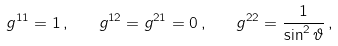Convert formula to latex. <formula><loc_0><loc_0><loc_500><loc_500>g ^ { 1 1 } = 1 \, , \quad g ^ { 1 2 } = g ^ { 2 1 } = 0 \, , \quad g ^ { 2 2 } = \frac { 1 } { \sin ^ { 2 } \vartheta } \, ,</formula> 